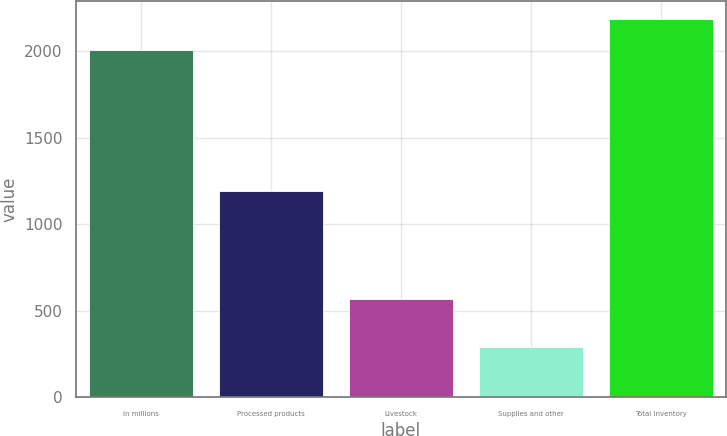<chart> <loc_0><loc_0><loc_500><loc_500><bar_chart><fcel>in millions<fcel>Processed products<fcel>Livestock<fcel>Supplies and other<fcel>Total inventory<nl><fcel>2006<fcel>1192<fcel>571<fcel>294<fcel>2182.3<nl></chart> 